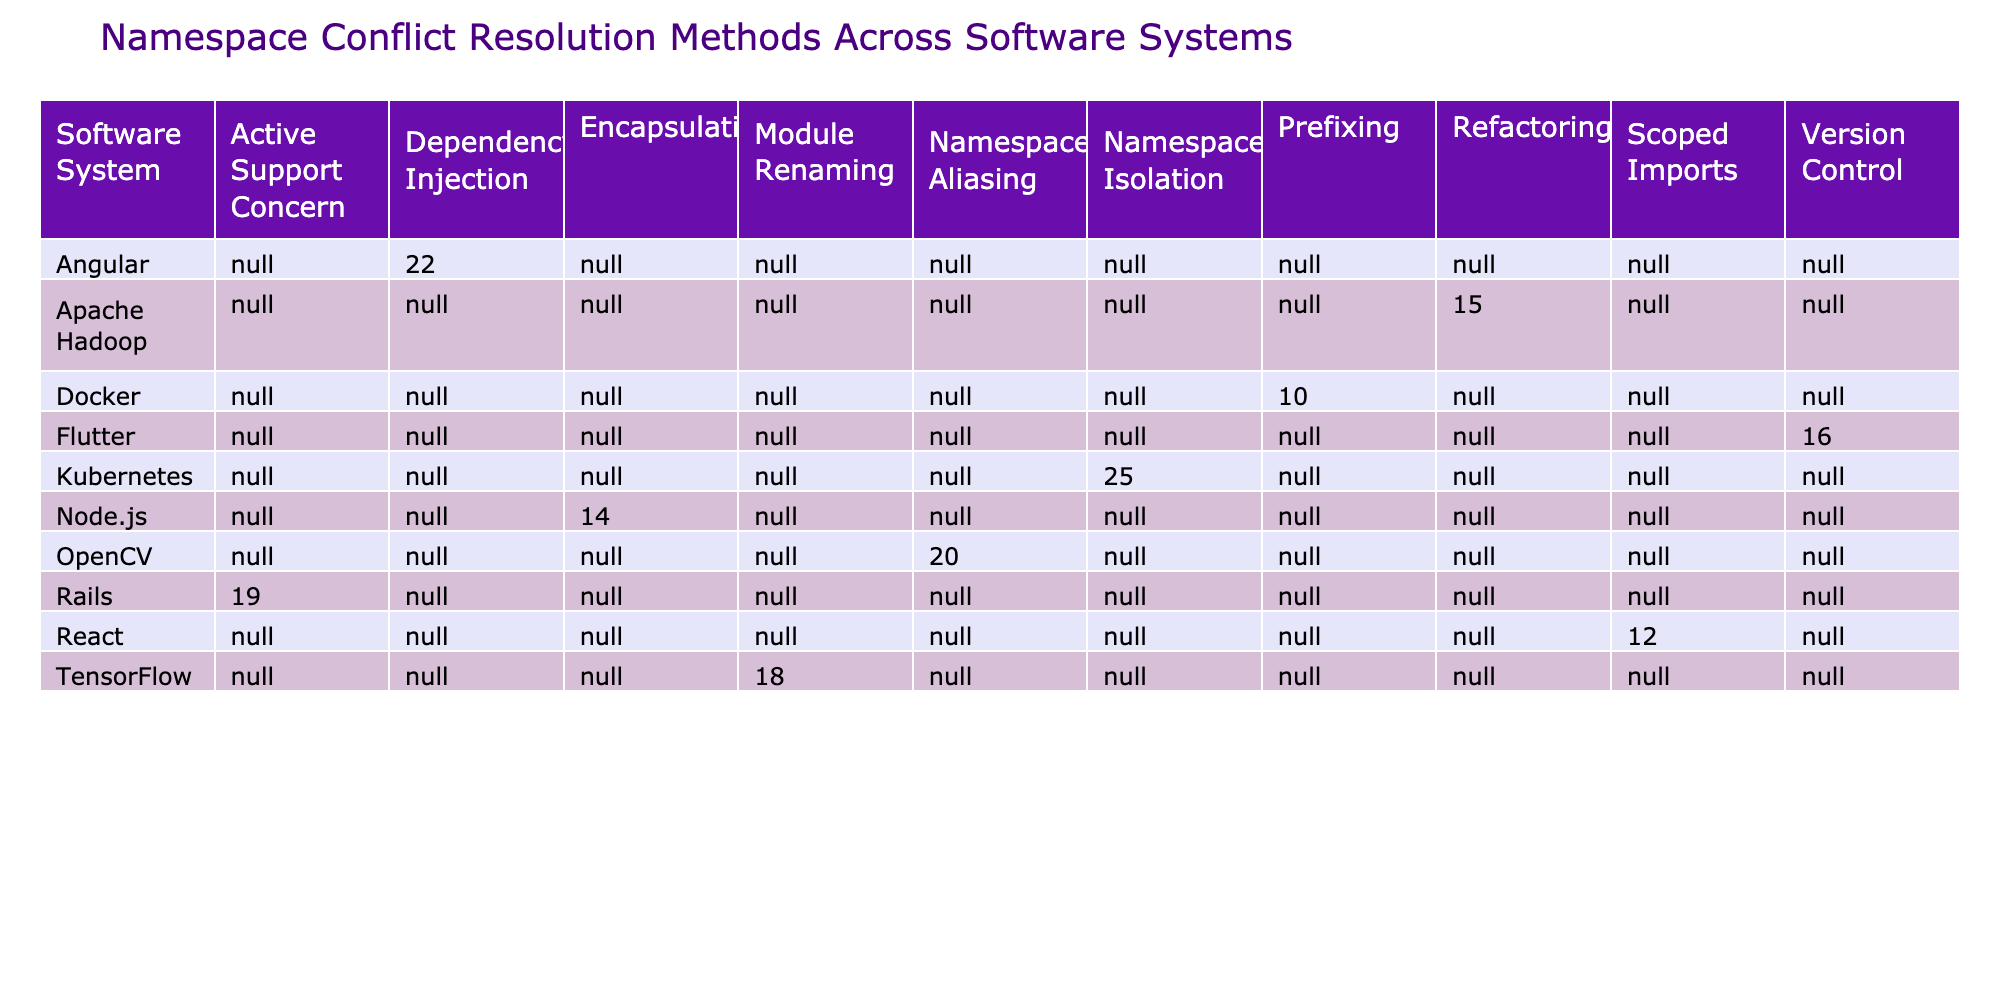What is the namespace conflict frequency of Kubernetes? By looking at the column for Namespace Conflict Frequency corresponding to the row for Kubernetes, the value is 25.
Answer: 25 Which resolution method has the highest frequency of namespace conflicts? Scanning through the resolution methods, Namespace Isolation corresponding to Kubernetes has the highest frequency, which is 25.
Answer: Namespace Isolation What is the total frequency of namespace conflicts for software systems that utilize Refactoring? Only Apache Hadoop uses Refactoring, with a frequency of 15. Therefore, the total is 15.
Answer: 15 Is the frequency of namespace conflicts for Docker less than that for Flutter? The frequency for Docker is 10, whereas for Flutter it is 16. Since 10 is less than 16, the answer is yes.
Answer: Yes What is the average frequency of namespace conflicts across all software systems listed? First, sum the frequencies: 15 + 25 + 10 + 18 + 12 + 20 + 16 + 22 + 14 + 19 =  171. There are 10 software systems, so the average is 171/10 = 17.1.
Answer: 17.1 Which resolution method is used by Angular, and how many conflicts does it have? Angular uses Dependency Injection as its resolution method with a frequency of 22.
Answer: Dependency Injection, 22 What is the difference in namespace conflict frequency between TensorFlow and OpenCV? The frequency for TensorFlow is 18 and for OpenCV is 20. The difference is 20 - 18 = 2.
Answer: 2 How many software systems use Namespace Aliasing as a resolution method? Only OpenCV utilizes Namespace Aliasing for its conflicts, so the count is 1.
Answer: 1 Is there any software system with a frequency of conflicts greater than 20? Yes, Kubernetes (25) and Angular (22) have frequencies greater than 20.
Answer: Yes 